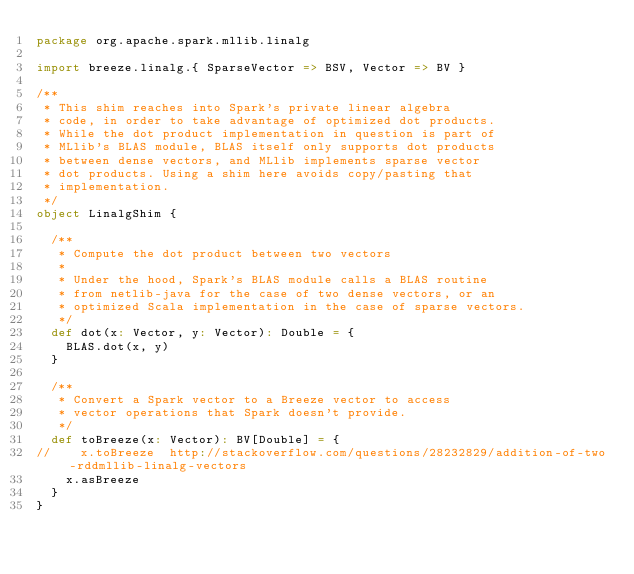<code> <loc_0><loc_0><loc_500><loc_500><_Scala_>package org.apache.spark.mllib.linalg

import breeze.linalg.{ SparseVector => BSV, Vector => BV }

/**
 * This shim reaches into Spark's private linear algebra
 * code, in order to take advantage of optimized dot products.
 * While the dot product implementation in question is part of
 * MLlib's BLAS module, BLAS itself only supports dot products
 * between dense vectors, and MLlib implements sparse vector
 * dot products. Using a shim here avoids copy/pasting that
 * implementation.
 */
object LinalgShim {

  /**
   * Compute the dot product between two vectors
   *
   * Under the hood, Spark's BLAS module calls a BLAS routine
   * from netlib-java for the case of two dense vectors, or an
   * optimized Scala implementation in the case of sparse vectors.
   */
  def dot(x: Vector, y: Vector): Double = {
    BLAS.dot(x, y)
  }

  /**
   * Convert a Spark vector to a Breeze vector to access
   * vector operations that Spark doesn't provide.
   */
  def toBreeze(x: Vector): BV[Double] = {
//    x.toBreeze  http://stackoverflow.com/questions/28232829/addition-of-two-rddmllib-linalg-vectors
    x.asBreeze
  }
}
</code> 